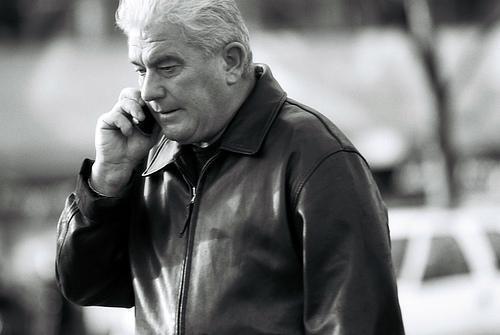How many of the bowls in the image contain mushrooms?
Give a very brief answer. 0. 